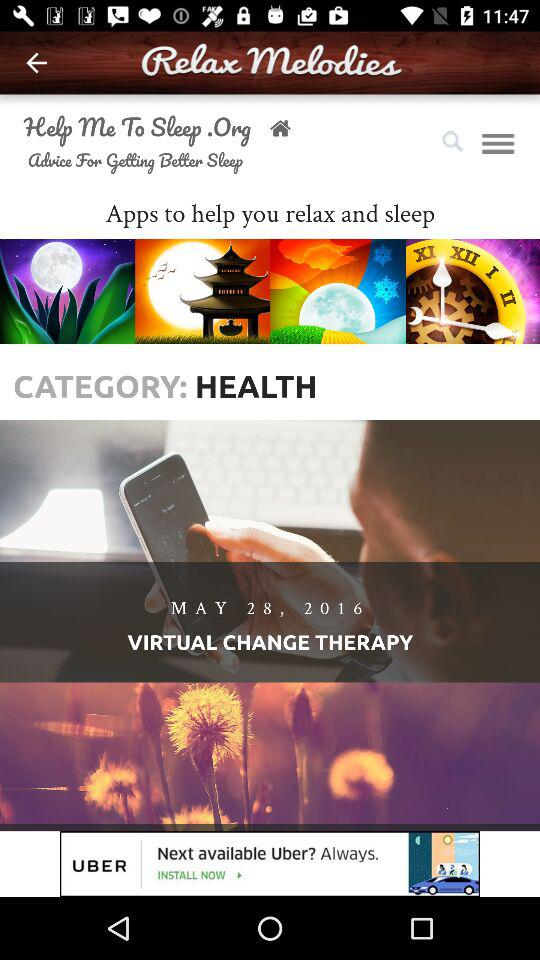What is the application name? The application name is "Relax Melodies". 